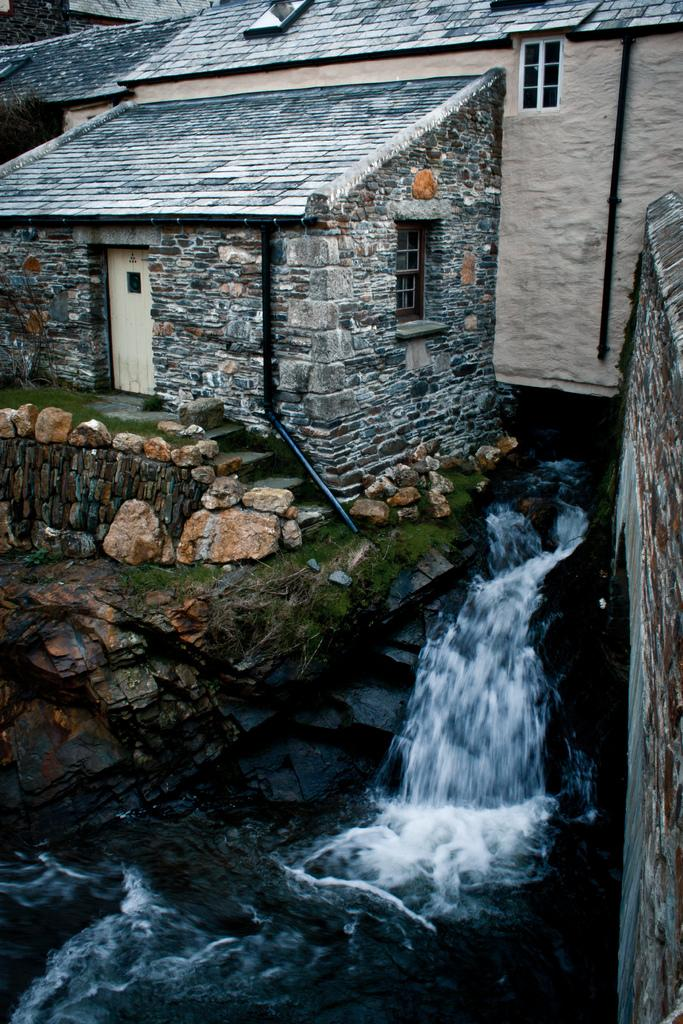What type of structure is present in the image? There is a building in the image. What natural element can be seen in the image? There is water visible in the image. What type of material is present in the image? There are stones in the image. What type of vegetation is present in the image? There is grass in the image. What type of shoe can be seen in the image? There is no shoe present in the image. What type of shade is provided by the building in the image? The image does not provide information about the shade provided by the building. 